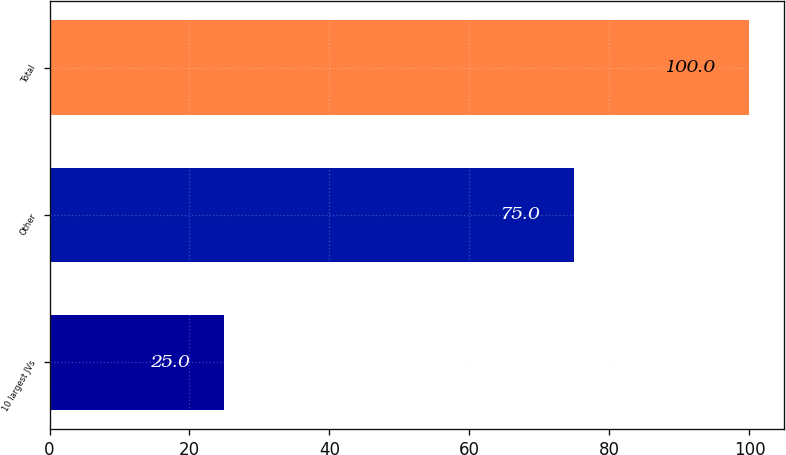Convert chart. <chart><loc_0><loc_0><loc_500><loc_500><bar_chart><fcel>10 largest JVs<fcel>Other<fcel>Total<nl><fcel>25<fcel>75<fcel>100<nl></chart> 